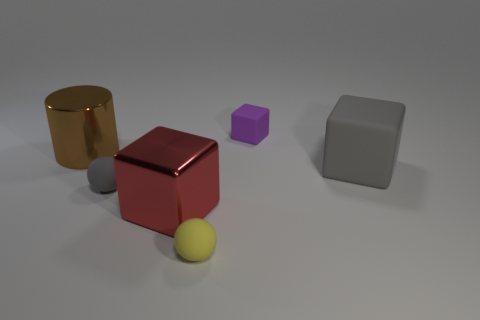What number of other objects are the same size as the brown thing?
Your answer should be very brief. 2. What number of big red cubes are made of the same material as the gray cube?
Give a very brief answer. 0. What is the material of the big object that is behind the large red shiny thing and left of the yellow ball?
Your response must be concise. Metal. What shape is the tiny gray object behind the yellow sphere?
Provide a short and direct response. Sphere. There is a gray object that is on the right side of the cube that is behind the brown metallic cylinder; what is its shape?
Offer a terse response. Cube. Is there another large object that has the same shape as the big red metallic thing?
Keep it short and to the point. Yes. There is another shiny thing that is the same size as the brown metallic object; what shape is it?
Ensure brevity in your answer.  Cube. Is there a big red shiny block that is in front of the gray matte object that is in front of the rubber block that is on the right side of the small purple object?
Offer a terse response. Yes. Is there a red cylinder of the same size as the red block?
Keep it short and to the point. No. How big is the thing right of the tiny purple matte thing?
Ensure brevity in your answer.  Large. 